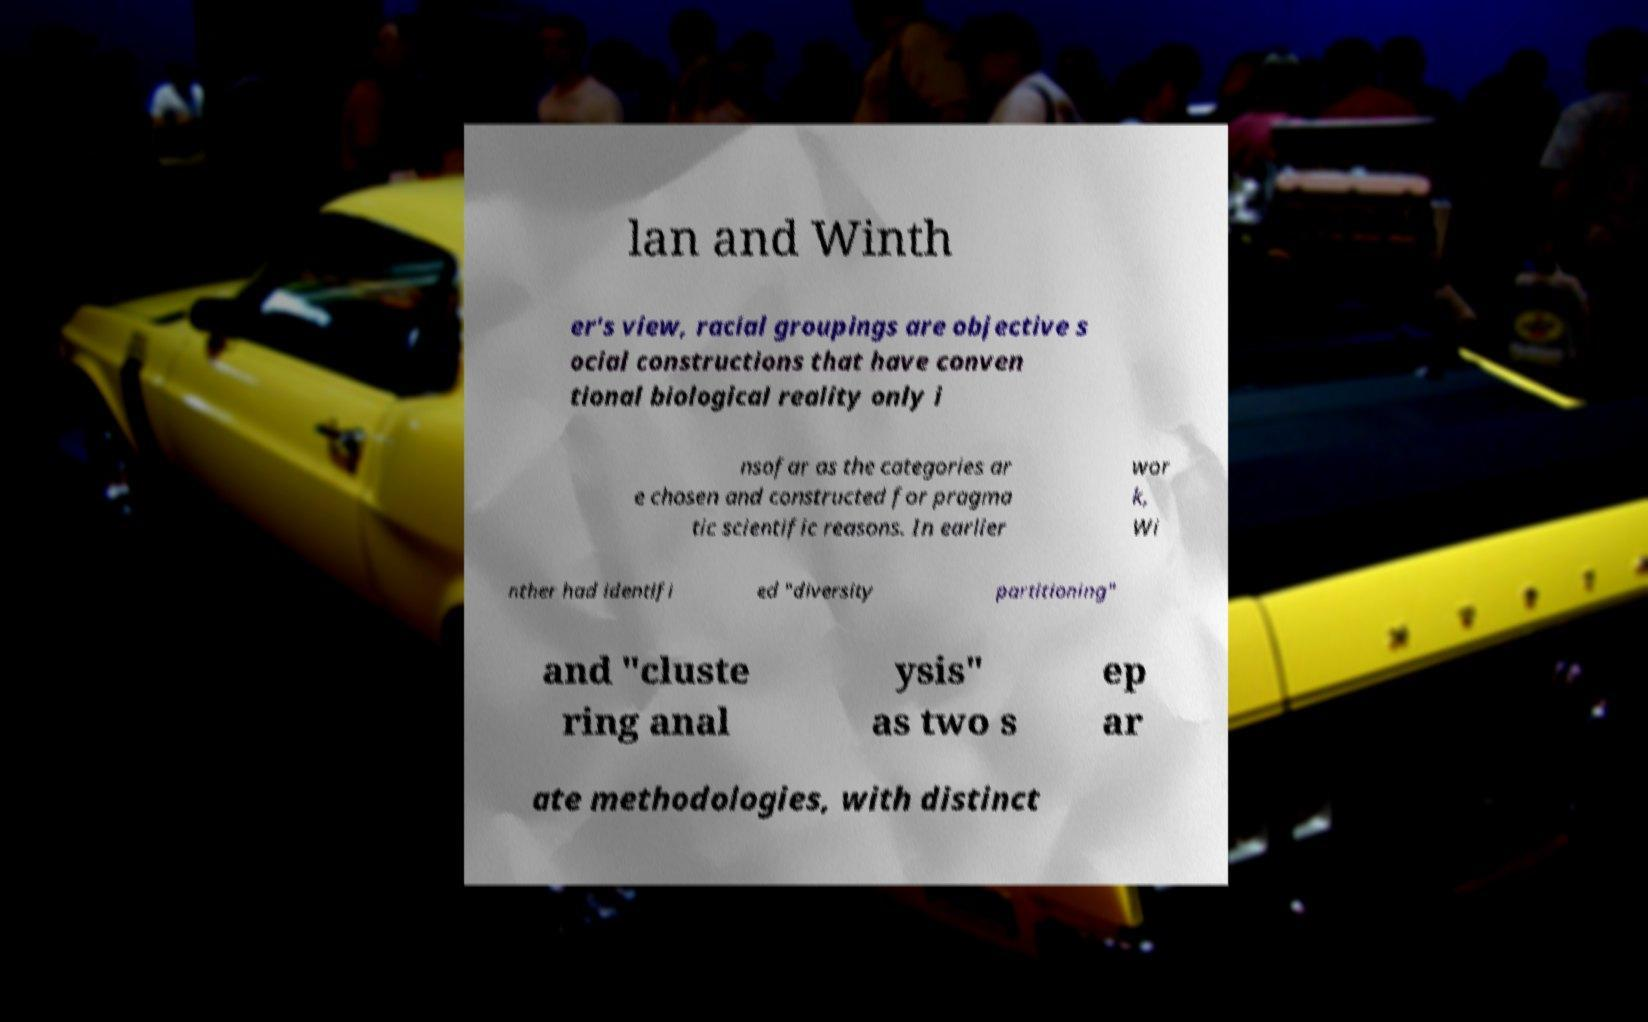Please identify and transcribe the text found in this image. lan and Winth er's view, racial groupings are objective s ocial constructions that have conven tional biological reality only i nsofar as the categories ar e chosen and constructed for pragma tic scientific reasons. In earlier wor k, Wi nther had identifi ed "diversity partitioning" and "cluste ring anal ysis" as two s ep ar ate methodologies, with distinct 